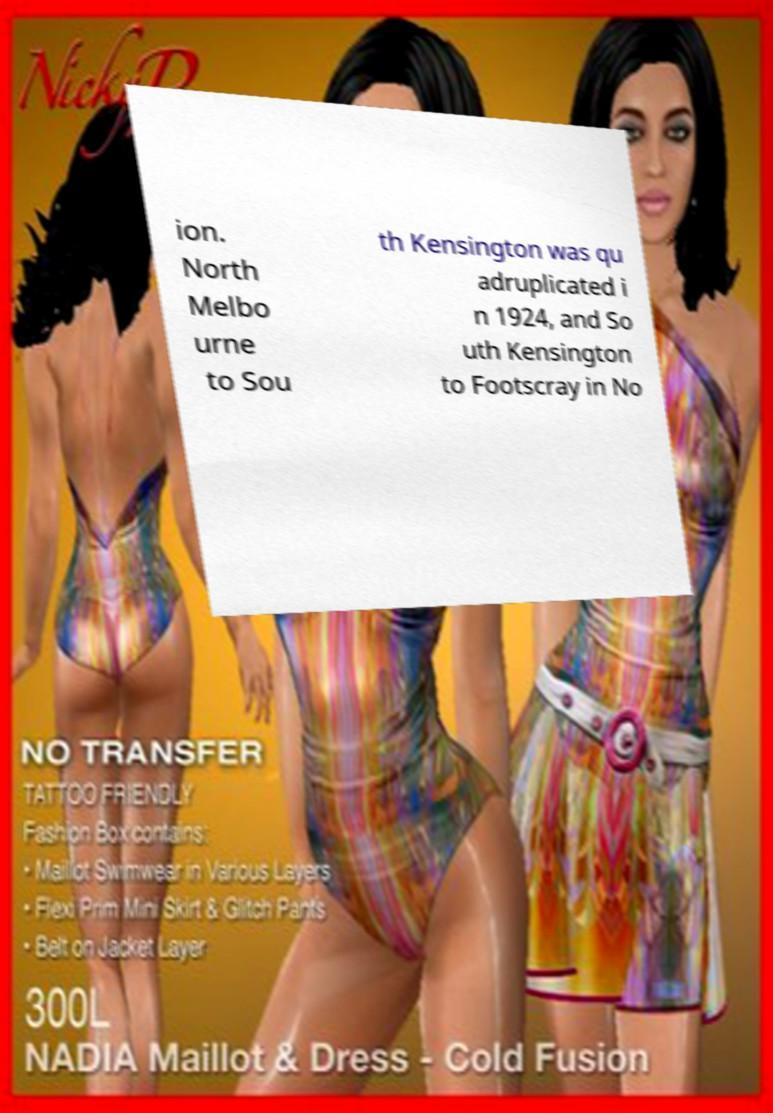Could you extract and type out the text from this image? ion. North Melbo urne to Sou th Kensington was qu adruplicated i n 1924, and So uth Kensington to Footscray in No 